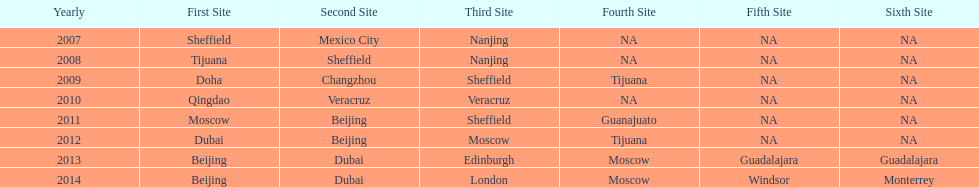In which year was there a higher count of venues, 2007 or 2012? 2012. 